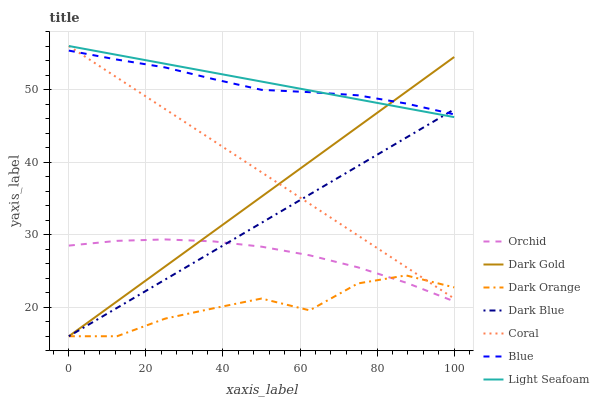Does Dark Orange have the minimum area under the curve?
Answer yes or no. Yes. Does Light Seafoam have the maximum area under the curve?
Answer yes or no. Yes. Does Dark Gold have the minimum area under the curve?
Answer yes or no. No. Does Dark Gold have the maximum area under the curve?
Answer yes or no. No. Is Dark Blue the smoothest?
Answer yes or no. Yes. Is Dark Orange the roughest?
Answer yes or no. Yes. Is Dark Gold the smoothest?
Answer yes or no. No. Is Dark Gold the roughest?
Answer yes or no. No. Does Coral have the lowest value?
Answer yes or no. No. Does Dark Gold have the highest value?
Answer yes or no. No. Is Dark Orange less than Blue?
Answer yes or no. Yes. Is Blue greater than Orchid?
Answer yes or no. Yes. Does Dark Orange intersect Blue?
Answer yes or no. No. 